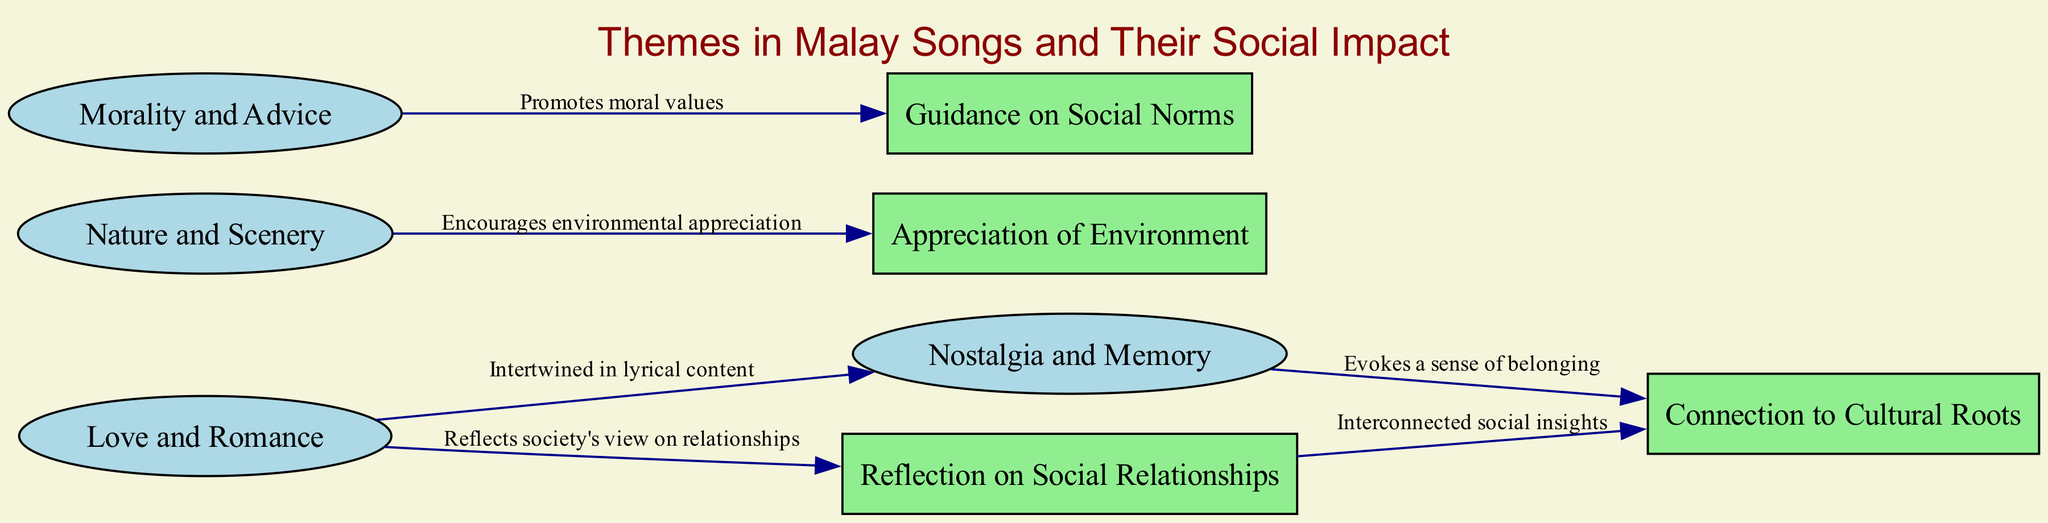What are the four themes represented in the diagram? The diagram has nodes for "Love and Romance," "Nostalgia and Memory," "Nature and Scenery," and "Morality and Advice." I can directly identify these themes from the nodes labeled under the "themes" category.
Answer: Love and Romance, Nostalgia and Memory, Nature and Scenery, Morality and Advice How many social impacts are associated with the themes? The diagram displays four social impacts connected to the themes: "Reflection on Social Relationships," "Connection to Cultural Roots," "Appreciation of Environment," and "Guidance on Social Norms." Counting these nodes gives the total.
Answer: 4 What does the theme "Love and Romance" reflect about society? The edge from "Love and Romance" to "Reflection on Social Relationships" indicates that this theme reflects society's view on relationships; I found that directly stated in the edge label.
Answer: Reflects society's view on relationships Which theme is connected to "Connection to Cultural Roots"? I can see that "Nostalgia and Memory" is connected to "Connection to Cultural Roots," as shown by the edge leading from "themes_nostalgia" to "social_impact_nostalgia." The label explicitly states the connection.
Answer: Nostalgia and Memory How many edges are there in the diagram? By observing the diagram, I can enumerate the edges linking the nodes. There are five edges in total that illustrate the connections between themes and their social impacts.
Answer: 5 What theme is intertwined with "Love and Romance"? The edge label connecting "Love and Romance" to "Nostalgia and Memory" denotes that they are intertwined in lyrical content, which I deduce from following the label of that edge.
Answer: Nostalgia and Memory What social impact is associated with "Nature and Scenery"? Following the edge from "Nature and Scenery," I can see that it connects to "Appreciation of Environment." The label of this edge describes the relationship accordingly.
Answer: Appreciation of Environment Which social impact connects indirectly through "Reflection on Social Relationships"? The edge from "Reflection on Social Relationships" to "Connection to Cultural Roots" indicates there are interconnected social insights; by following the edges, it's clear that both nodes inform this deeper understanding.
Answer: Connection to Cultural Roots What is the primary moral message reflected in the diagram? The theme "Morality and Advice" leads to the social impact "Guidance on Social Norms," which indicates that the primary moral message is promoting moral values as suggested by the edge label.
Answer: Promotes moral values 